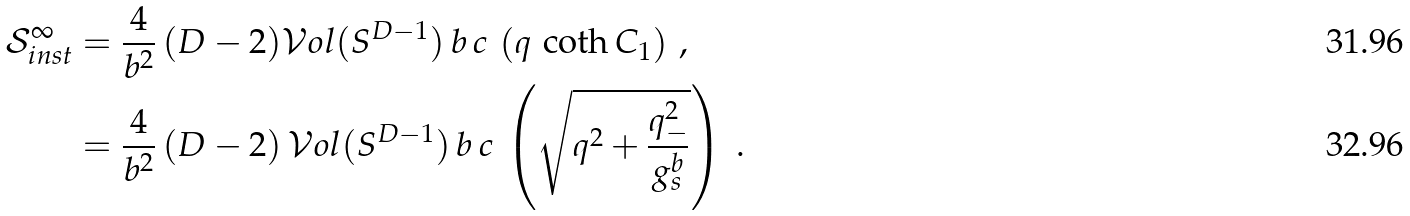Convert formula to latex. <formula><loc_0><loc_0><loc_500><loc_500>\mathcal { S } ^ { \infty } _ { i n s t } & = \frac { 4 } { b ^ { 2 } } \, ( D - 2 ) \mathcal { V } o l ( S ^ { D - 1 } ) \, { b \, c } \, \left ( q \, \coth C _ { 1 } \right ) \, , \\ & = \frac { 4 } { b ^ { 2 } } \, ( D - 2 ) \, \mathcal { V } o l ( S ^ { D - 1 } ) \, b \, c \, \left ( \sqrt { q ^ { 2 } + \frac { q _ { - } ^ { 2 } } { g _ { s } ^ { b } } } \right ) \ .</formula> 